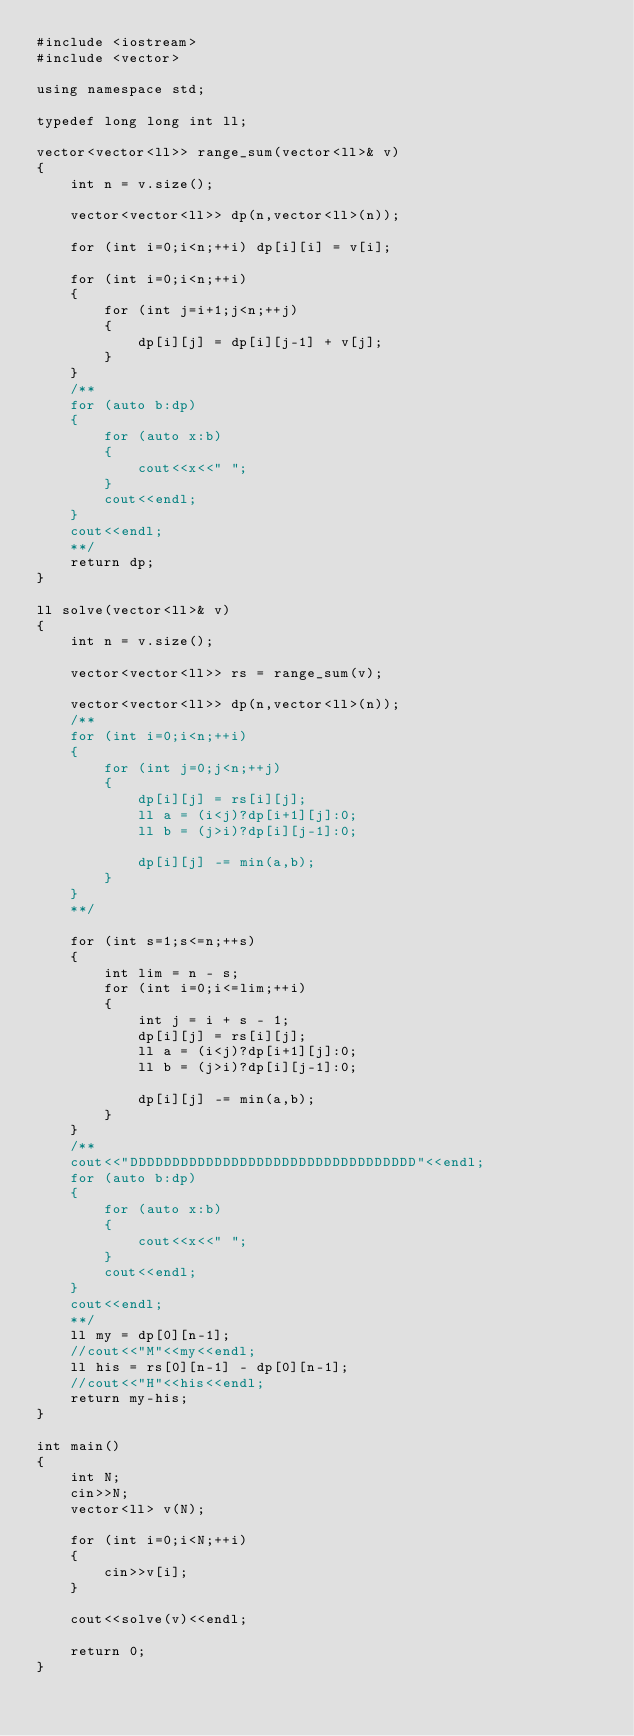Convert code to text. <code><loc_0><loc_0><loc_500><loc_500><_C++_>#include <iostream>
#include <vector>

using namespace std;

typedef long long int ll;

vector<vector<ll>> range_sum(vector<ll>& v)
{
    int n = v.size();

    vector<vector<ll>> dp(n,vector<ll>(n));

    for (int i=0;i<n;++i) dp[i][i] = v[i];

    for (int i=0;i<n;++i)
    {
        for (int j=i+1;j<n;++j)
        {
            dp[i][j] = dp[i][j-1] + v[j];
        }
    }
    /**
    for (auto b:dp)
    {
        for (auto x:b)
        {
            cout<<x<<" ";
        }
        cout<<endl;
    }
    cout<<endl;
    **/
    return dp;
}

ll solve(vector<ll>& v)
{
    int n = v.size();

    vector<vector<ll>> rs = range_sum(v);

    vector<vector<ll>> dp(n,vector<ll>(n));
    /**
    for (int i=0;i<n;++i)
    {
        for (int j=0;j<n;++j)
        {
            dp[i][j] = rs[i][j];
            ll a = (i<j)?dp[i+1][j]:0;
            ll b = (j>i)?dp[i][j-1]:0;

            dp[i][j] -= min(a,b);
        }
    }
    **/

    for (int s=1;s<=n;++s)
    {
        int lim = n - s;
        for (int i=0;i<=lim;++i)
        {
            int j = i + s - 1;
            dp[i][j] = rs[i][j];
            ll a = (i<j)?dp[i+1][j]:0;
            ll b = (j>i)?dp[i][j-1]:0;

            dp[i][j] -= min(a,b);
        }
    }
    /**
    cout<<"DDDDDDDDDDDDDDDDDDDDDDDDDDDDDDDDDD"<<endl;
    for (auto b:dp)
    {
        for (auto x:b)
        {
            cout<<x<<" ";
        }
        cout<<endl;
    }
    cout<<endl;
    **/
    ll my = dp[0][n-1];
    //cout<<"M"<<my<<endl;
    ll his = rs[0][n-1] - dp[0][n-1];
    //cout<<"H"<<his<<endl;
    return my-his;
}

int main()
{
    int N;
    cin>>N;
    vector<ll> v(N);

    for (int i=0;i<N;++i)
    {
        cin>>v[i];
    }

    cout<<solve(v)<<endl;

    return 0;
}
</code> 